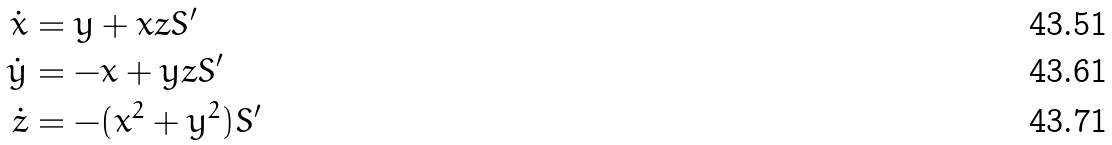<formula> <loc_0><loc_0><loc_500><loc_500>\dot { x } & = y + x z S ^ { \prime } \\ \dot { y } & = - x + y z S ^ { \prime } \\ \dot { z } & = - ( x ^ { 2 } + y ^ { 2 } ) S ^ { \prime }</formula> 